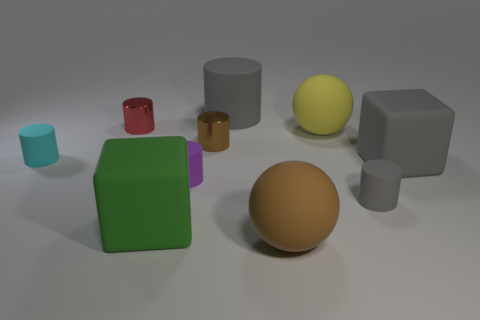What number of matte things are either tiny cyan objects or large brown spheres?
Make the answer very short. 2. There is a cyan thing that is made of the same material as the small purple thing; what is its shape?
Offer a terse response. Cylinder. How many small cyan objects are the same shape as the tiny red thing?
Your response must be concise. 1. Does the large gray matte thing in front of the tiny cyan rubber cylinder have the same shape as the big gray object that is left of the small gray rubber thing?
Provide a succinct answer. No. What number of objects are small brown things or gray cylinders that are behind the small brown object?
Your answer should be very brief. 2. The small thing that is the same color as the big rubber cylinder is what shape?
Ensure brevity in your answer.  Cylinder. What number of gray cubes are the same size as the red cylinder?
Make the answer very short. 0. What number of red objects are tiny cylinders or matte blocks?
Give a very brief answer. 1. There is a large gray object on the right side of the brown thing that is in front of the small brown object; what shape is it?
Offer a terse response. Cube. The yellow object that is the same size as the brown matte thing is what shape?
Your answer should be very brief. Sphere. 